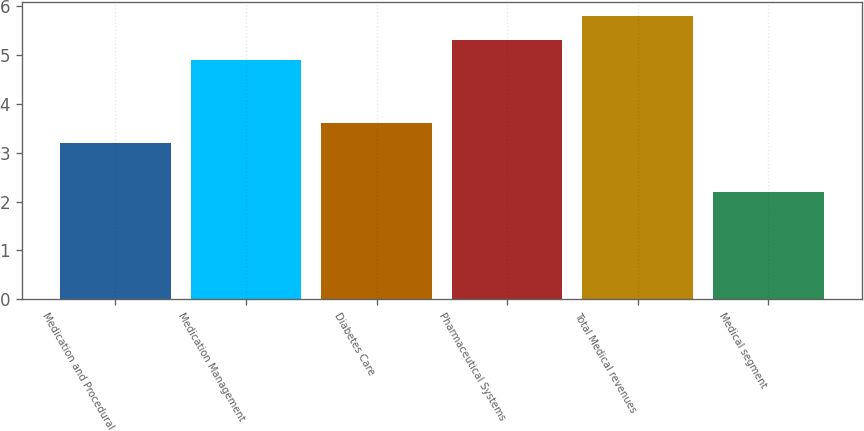Convert chart to OTSL. <chart><loc_0><loc_0><loc_500><loc_500><bar_chart><fcel>Medication and Procedural<fcel>Medication Management<fcel>Diabetes Care<fcel>Pharmaceutical Systems<fcel>Total Medical revenues<fcel>Medical segment<nl><fcel>3.2<fcel>4.9<fcel>3.6<fcel>5.3<fcel>5.8<fcel>2.2<nl></chart> 